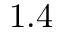Convert formula to latex. <formula><loc_0><loc_0><loc_500><loc_500>1 . 4</formula> 